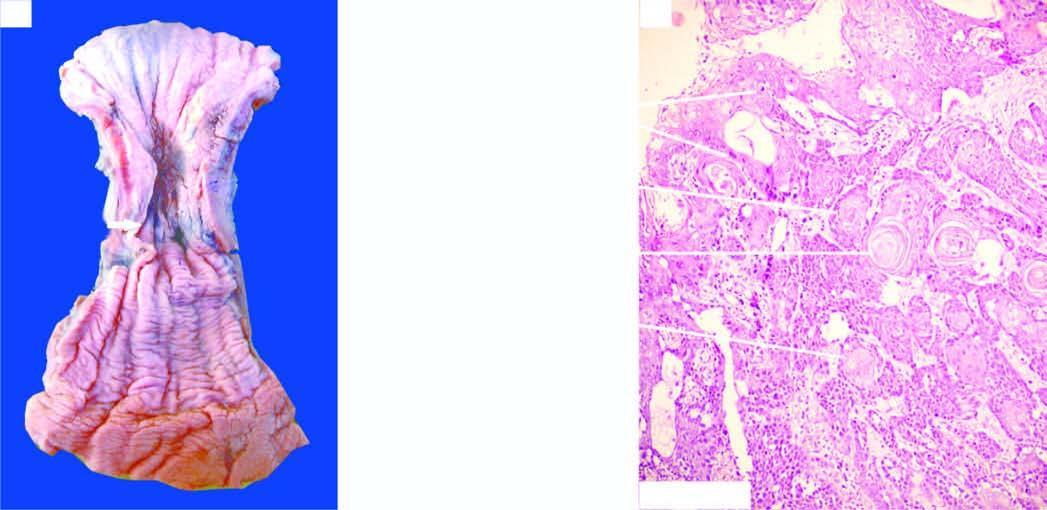what shows whorls of anaplastic squamous cells invading the underlying soft tissues?
Answer the question using a single word or phrase. Photomicrograph 